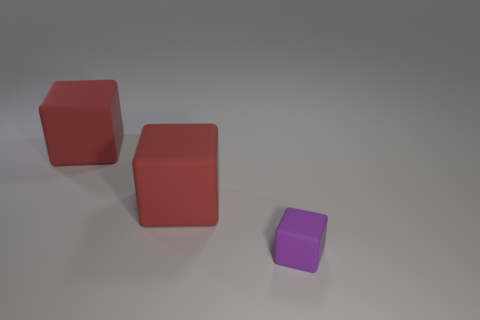What could be the significance of their arrangement? The arrangement of the blocks might illustrate concepts of depth and scale or could be used to demonstrate principles of perspective in photography. Their deliberate placement allows for an analysis of spatial relationships. 